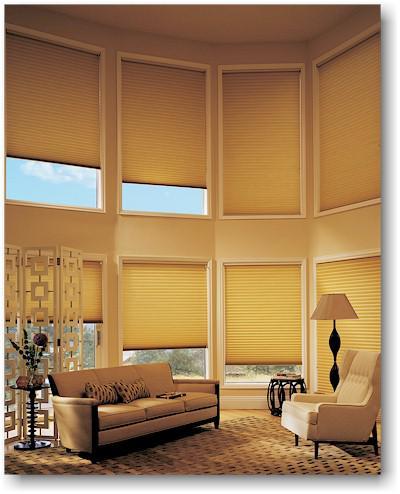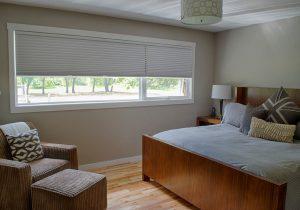The first image is the image on the left, the second image is the image on the right. Evaluate the accuracy of this statement regarding the images: "There are at least ten window panes.". Is it true? Answer yes or no. Yes. The first image is the image on the left, the second image is the image on the right. Examine the images to the left and right. Is the description "Four sets of blinds are partially opened at the top of the window." accurate? Answer yes or no. No. 